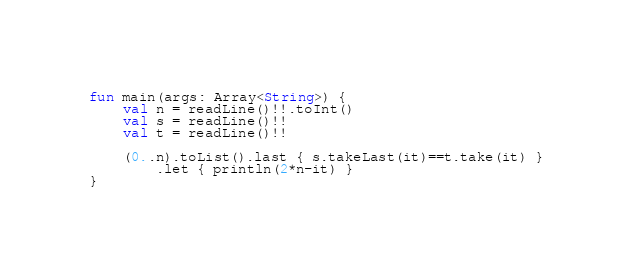<code> <loc_0><loc_0><loc_500><loc_500><_Kotlin_>fun main(args: Array<String>) {
    val n = readLine()!!.toInt()
    val s = readLine()!!
    val t = readLine()!!

    (0..n).toList().last { s.takeLast(it)==t.take(it) }
        .let { println(2*n-it) }
}</code> 